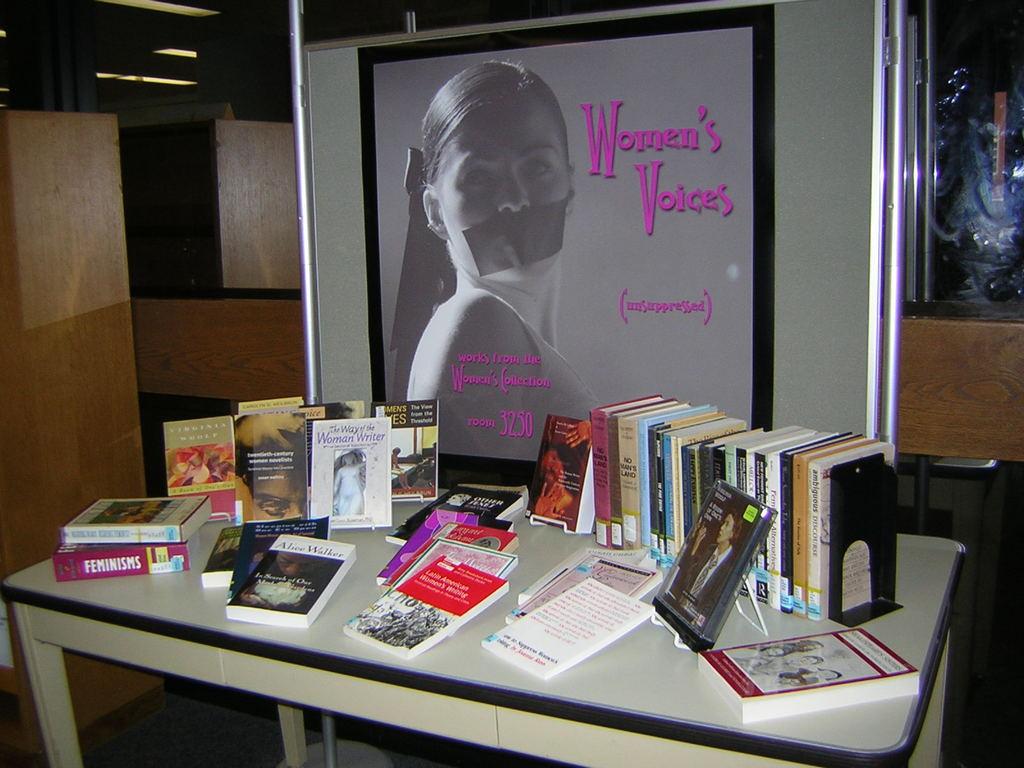Whos voice is mentioned in the picture?
Your response must be concise. Women's. What is written in pink?
Offer a very short reply. Women's voices. 